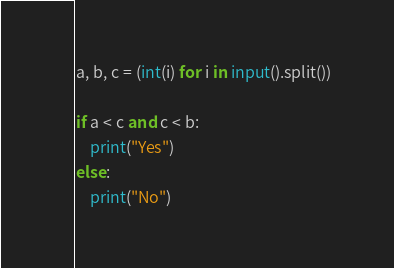<code> <loc_0><loc_0><loc_500><loc_500><_Python_>
a, b, c = (int(i) for i in input().split()) 

if a < c and c < b:
    print("Yes")
else:
    print("No")</code> 